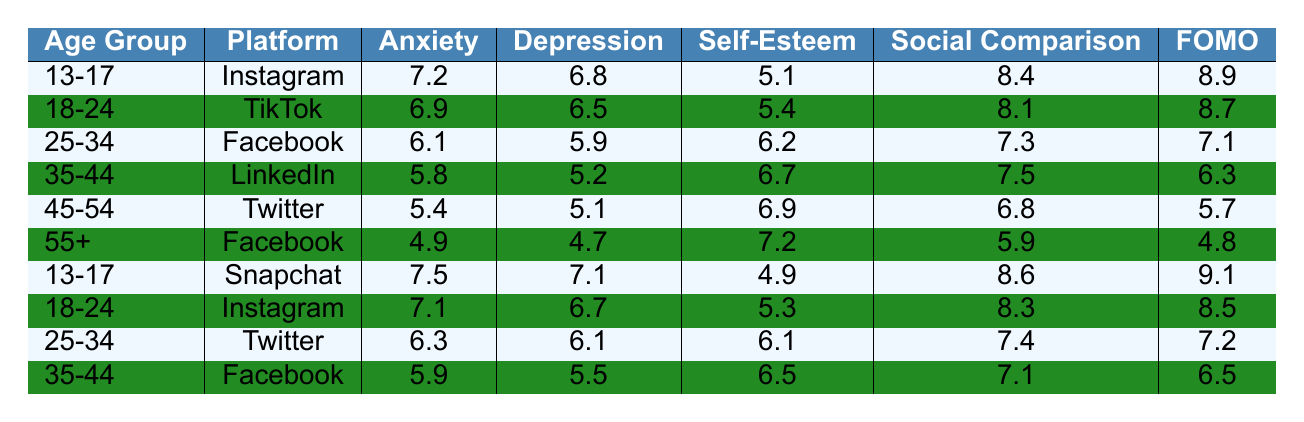What is the anxiety level for the age group 45-54 on Twitter? For the age group 45-54 on Twitter, the anxiety level is directly listed in the table as 5.4.
Answer: 5.4 Which age group has the highest self-esteem when using Snapchat? The only age group that uses Snapchat in the table is 13-17, with a self-esteem score of 4.9.
Answer: 4.9 What is the average depression score across all age groups for Facebook? The depression scores for Facebook in the table are: 5.1 (45-54), 4.7 (55+), and 5.5 (35-44) totaling 15.3. Dividing this by 3 gives an average of 15.3/3 = 5.1.
Answer: 5.1 Is the FOMO index higher for the 18-24 age group on TikTok or for the 13-17 age group on Snapchat? The FOMO index for 18-24 on TikTok is 8.7, while for 13-17 on Snapchat it is 9.1. Since 9.1 > 8.7, the FOMO index for 13-17 on Snapchat is higher.
Answer: Yes How does the social comparison score of the 25-34 age group on Twitter compare to the score of the 35-44 age group on Facebook? The social comparison score for the 25-34 age group on Twitter is 7.4 and for the 35-44 age group on Facebook is 7.1. Since 7.4 > 7.1, the 25-34 age group has a higher score.
Answer: 25-34 age group on Twitter has a higher score What are the average anxiety levels for the age group 13-17 across all platforms? The anxiety levels for 13-17 on Instagram and Snapchat are 7.2 and 7.5 respectively. Their total is 14.7, and the average is 14.7/2 = 7.35.
Answer: 7.35 For which platform does the age group 55+ exhibit the lowest addiction risk? The addiction risk for 55+ using Facebook is 4.6, while there are no other platforms listed for this age group. Thus, it is the only value.
Answer: 4.6 Is self-esteem generally higher for the 35-44 age group using LinkedIn compared to the 18-24 age group using Instagram? The self-esteem for 35-44 on LinkedIn is 6.7, while for 18-24 on Instagram it is 5.3. Since 6.7 > 5.3, 35-44 on LinkedIn has a higher self-esteem.
Answer: Yes Which age group and platform combination has the highest FOMO index? The highest FOMO index in the table is 9.1 for the 13-17 age group on Snapchat.
Answer: 13-17 on Snapchat What is the difference in depression scores between the 25-34 age group on Facebook and the 45-54 age group on Twitter? The depression score for the 25-34 age group on Facebook is 5.9 and for the 45-54 age group on Twitter is 5.1. The difference is 5.9 - 5.1 = 0.8.
Answer: 0.8 